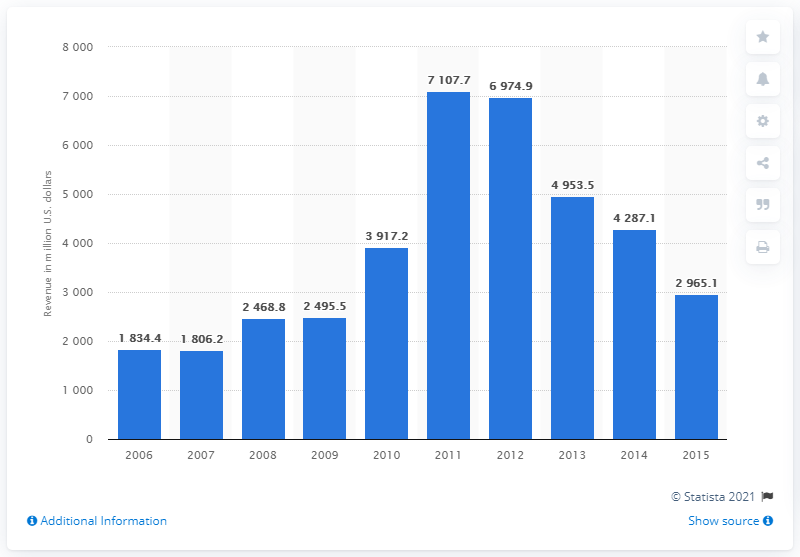Highlight a few significant elements in this photo. Alpha Natural Resources generated $1,834.4 million in revenue in 2006. 